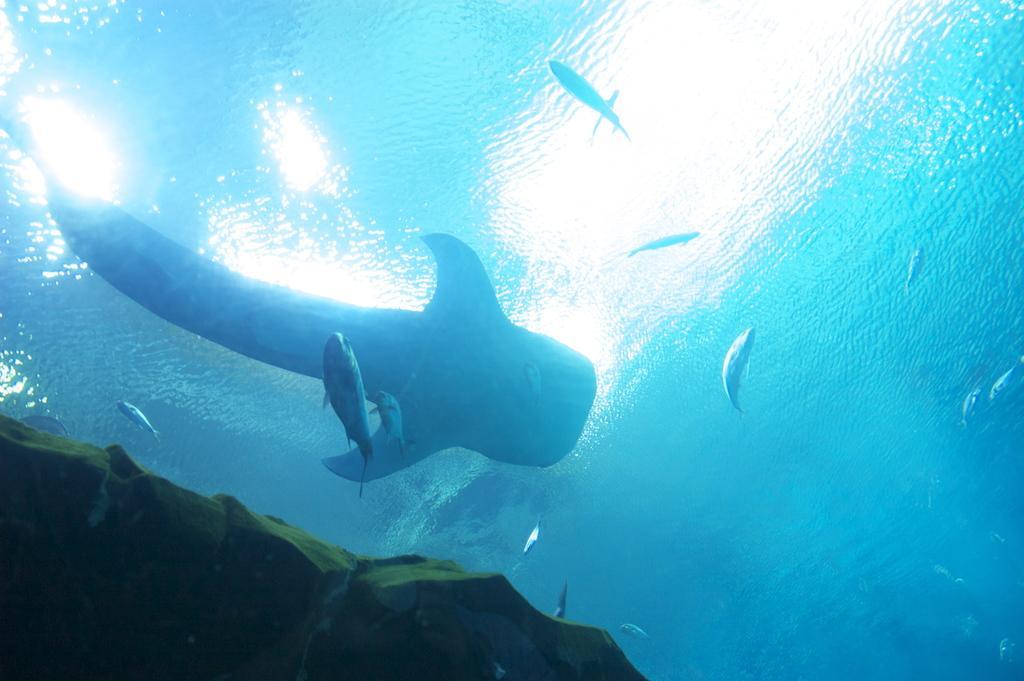In one or two sentences, can you explain what this image depicts? In this image we can see the fishes and rock underwater. 